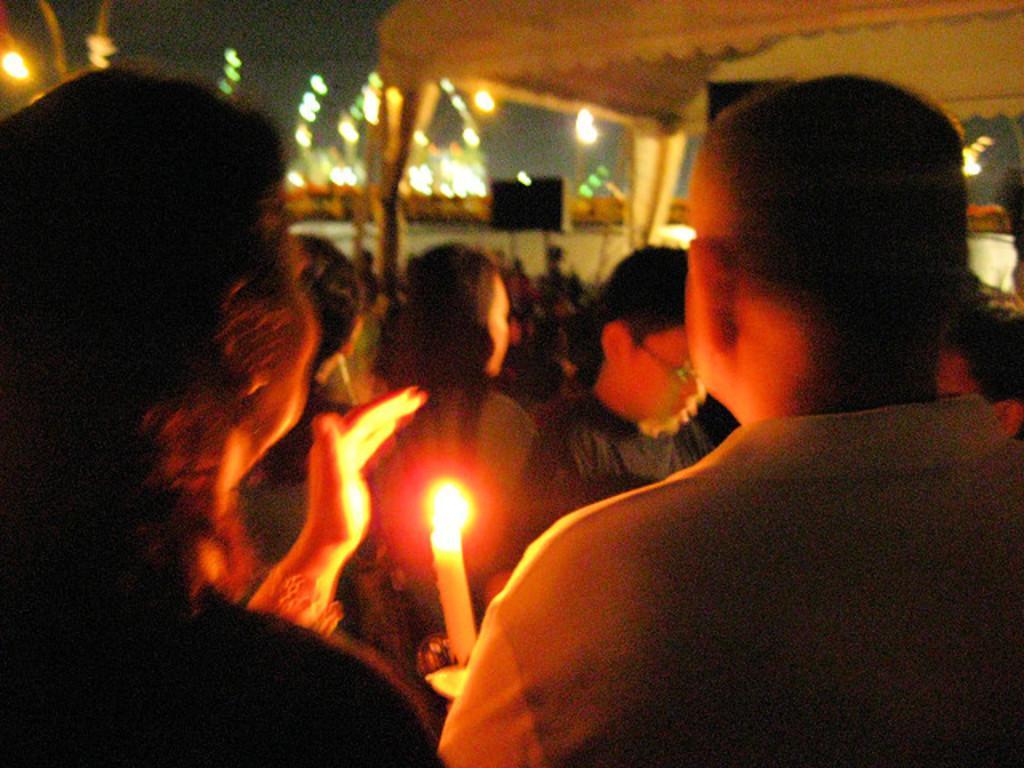How would you summarize this image in a sentence or two? In this image we can see these people are standing and we can see candle here. In the background, we can see a few more people standing here, tent, lights, board and the dark sky. 